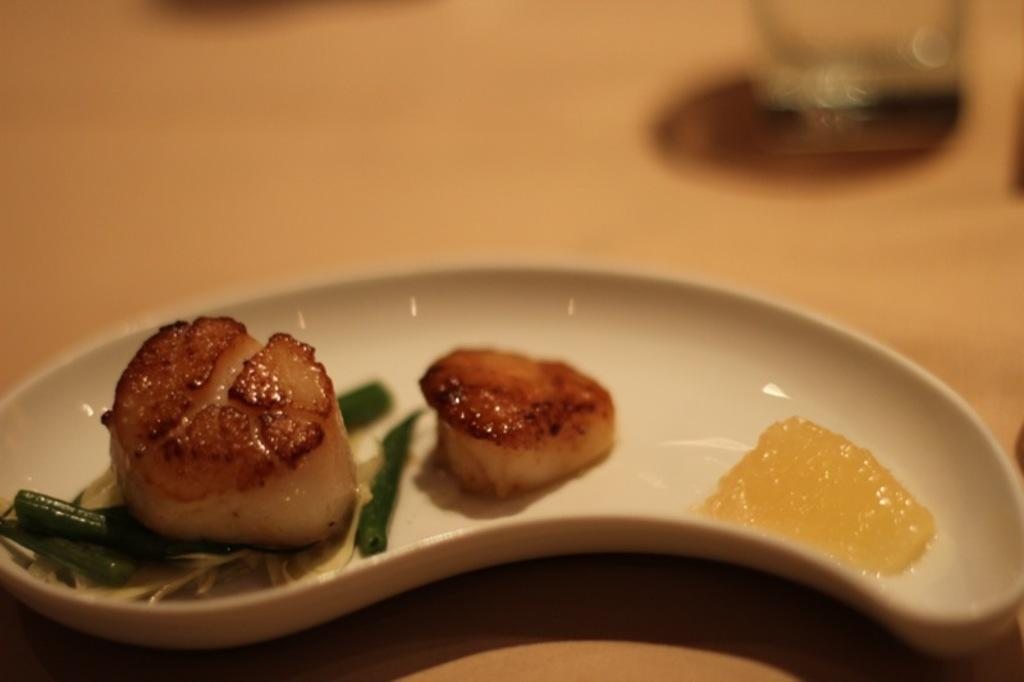What is the main subject of the image? The main subject of the image is food. How is the food presented in the image? The food is on a white plate. What colors can be seen in the food? The food has brown, green, and cream colors. What is the color of the background in the image? The background of the image is brown. How many books are stacked on the yak in the image? There is no yak or books present in the image; it features food on a white plate with a brown background. 